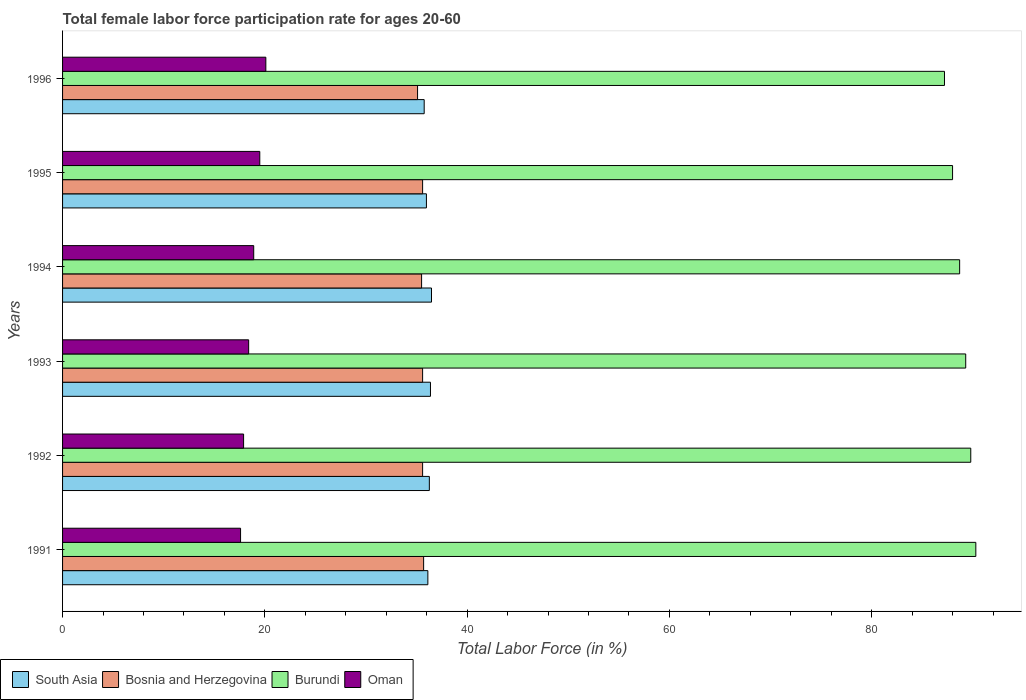How many different coloured bars are there?
Your answer should be compact. 4. How many groups of bars are there?
Offer a terse response. 6. How many bars are there on the 3rd tick from the top?
Offer a terse response. 4. How many bars are there on the 5th tick from the bottom?
Give a very brief answer. 4. What is the label of the 2nd group of bars from the top?
Ensure brevity in your answer.  1995. What is the female labor force participation rate in South Asia in 1992?
Ensure brevity in your answer.  36.27. Across all years, what is the maximum female labor force participation rate in Bosnia and Herzegovina?
Your answer should be very brief. 35.7. Across all years, what is the minimum female labor force participation rate in Oman?
Offer a very short reply. 17.6. In which year was the female labor force participation rate in South Asia maximum?
Provide a succinct answer. 1994. What is the total female labor force participation rate in South Asia in the graph?
Provide a short and direct response. 216.97. What is the difference between the female labor force participation rate in Oman in 1992 and that in 1994?
Your answer should be compact. -1. What is the difference between the female labor force participation rate in Oman in 1992 and the female labor force participation rate in Burundi in 1994?
Your response must be concise. -70.8. What is the average female labor force participation rate in Burundi per year?
Offer a terse response. 88.88. In the year 1992, what is the difference between the female labor force participation rate in Burundi and female labor force participation rate in South Asia?
Offer a terse response. 53.53. What is the ratio of the female labor force participation rate in South Asia in 1994 to that in 1996?
Give a very brief answer. 1.02. Is the difference between the female labor force participation rate in Burundi in 1994 and 1996 greater than the difference between the female labor force participation rate in South Asia in 1994 and 1996?
Offer a very short reply. Yes. What is the difference between the highest and the second highest female labor force participation rate in Oman?
Provide a short and direct response. 0.6. What is the difference between the highest and the lowest female labor force participation rate in Burundi?
Your response must be concise. 3.1. Is it the case that in every year, the sum of the female labor force participation rate in South Asia and female labor force participation rate in Oman is greater than the sum of female labor force participation rate in Burundi and female labor force participation rate in Bosnia and Herzegovina?
Your answer should be very brief. No. What does the 4th bar from the top in 1994 represents?
Provide a succinct answer. South Asia. What does the 1st bar from the bottom in 1996 represents?
Make the answer very short. South Asia. Is it the case that in every year, the sum of the female labor force participation rate in Oman and female labor force participation rate in South Asia is greater than the female labor force participation rate in Burundi?
Your answer should be compact. No. Are all the bars in the graph horizontal?
Offer a very short reply. Yes. How many years are there in the graph?
Your answer should be compact. 6. What is the difference between two consecutive major ticks on the X-axis?
Keep it short and to the point. 20. Does the graph contain any zero values?
Your answer should be compact. No. Where does the legend appear in the graph?
Your answer should be very brief. Bottom left. How many legend labels are there?
Ensure brevity in your answer.  4. What is the title of the graph?
Give a very brief answer. Total female labor force participation rate for ages 20-60. Does "Djibouti" appear as one of the legend labels in the graph?
Keep it short and to the point. No. What is the label or title of the Y-axis?
Make the answer very short. Years. What is the Total Labor Force (in %) of South Asia in 1991?
Keep it short and to the point. 36.12. What is the Total Labor Force (in %) in Bosnia and Herzegovina in 1991?
Provide a short and direct response. 35.7. What is the Total Labor Force (in %) of Burundi in 1991?
Offer a very short reply. 90.3. What is the Total Labor Force (in %) of Oman in 1991?
Your answer should be very brief. 17.6. What is the Total Labor Force (in %) of South Asia in 1992?
Ensure brevity in your answer.  36.27. What is the Total Labor Force (in %) of Bosnia and Herzegovina in 1992?
Offer a very short reply. 35.6. What is the Total Labor Force (in %) in Burundi in 1992?
Ensure brevity in your answer.  89.8. What is the Total Labor Force (in %) in Oman in 1992?
Your answer should be very brief. 17.9. What is the Total Labor Force (in %) in South Asia in 1993?
Your answer should be compact. 36.38. What is the Total Labor Force (in %) of Bosnia and Herzegovina in 1993?
Offer a terse response. 35.6. What is the Total Labor Force (in %) of Burundi in 1993?
Keep it short and to the point. 89.3. What is the Total Labor Force (in %) of Oman in 1993?
Your answer should be compact. 18.4. What is the Total Labor Force (in %) of South Asia in 1994?
Provide a succinct answer. 36.48. What is the Total Labor Force (in %) in Bosnia and Herzegovina in 1994?
Your answer should be very brief. 35.5. What is the Total Labor Force (in %) in Burundi in 1994?
Your answer should be very brief. 88.7. What is the Total Labor Force (in %) in Oman in 1994?
Keep it short and to the point. 18.9. What is the Total Labor Force (in %) of South Asia in 1995?
Ensure brevity in your answer.  35.98. What is the Total Labor Force (in %) in Bosnia and Herzegovina in 1995?
Provide a short and direct response. 35.6. What is the Total Labor Force (in %) in Burundi in 1995?
Give a very brief answer. 88. What is the Total Labor Force (in %) of Oman in 1995?
Offer a very short reply. 19.5. What is the Total Labor Force (in %) of South Asia in 1996?
Keep it short and to the point. 35.76. What is the Total Labor Force (in %) of Bosnia and Herzegovina in 1996?
Provide a short and direct response. 35.1. What is the Total Labor Force (in %) in Burundi in 1996?
Your response must be concise. 87.2. What is the Total Labor Force (in %) of Oman in 1996?
Offer a very short reply. 20.1. Across all years, what is the maximum Total Labor Force (in %) in South Asia?
Keep it short and to the point. 36.48. Across all years, what is the maximum Total Labor Force (in %) in Bosnia and Herzegovina?
Keep it short and to the point. 35.7. Across all years, what is the maximum Total Labor Force (in %) in Burundi?
Provide a succinct answer. 90.3. Across all years, what is the maximum Total Labor Force (in %) in Oman?
Give a very brief answer. 20.1. Across all years, what is the minimum Total Labor Force (in %) of South Asia?
Provide a short and direct response. 35.76. Across all years, what is the minimum Total Labor Force (in %) in Bosnia and Herzegovina?
Your answer should be compact. 35.1. Across all years, what is the minimum Total Labor Force (in %) of Burundi?
Give a very brief answer. 87.2. Across all years, what is the minimum Total Labor Force (in %) in Oman?
Make the answer very short. 17.6. What is the total Total Labor Force (in %) of South Asia in the graph?
Ensure brevity in your answer.  216.97. What is the total Total Labor Force (in %) in Bosnia and Herzegovina in the graph?
Make the answer very short. 213.1. What is the total Total Labor Force (in %) of Burundi in the graph?
Your response must be concise. 533.3. What is the total Total Labor Force (in %) in Oman in the graph?
Offer a terse response. 112.4. What is the difference between the Total Labor Force (in %) of South Asia in 1991 and that in 1992?
Your response must be concise. -0.15. What is the difference between the Total Labor Force (in %) of Bosnia and Herzegovina in 1991 and that in 1992?
Your answer should be compact. 0.1. What is the difference between the Total Labor Force (in %) of Burundi in 1991 and that in 1992?
Offer a very short reply. 0.5. What is the difference between the Total Labor Force (in %) of South Asia in 1991 and that in 1993?
Provide a short and direct response. -0.26. What is the difference between the Total Labor Force (in %) of Oman in 1991 and that in 1993?
Make the answer very short. -0.8. What is the difference between the Total Labor Force (in %) in South Asia in 1991 and that in 1994?
Make the answer very short. -0.36. What is the difference between the Total Labor Force (in %) of Burundi in 1991 and that in 1994?
Your response must be concise. 1.6. What is the difference between the Total Labor Force (in %) of South Asia in 1991 and that in 1995?
Your answer should be compact. 0.14. What is the difference between the Total Labor Force (in %) of Burundi in 1991 and that in 1995?
Ensure brevity in your answer.  2.3. What is the difference between the Total Labor Force (in %) in South Asia in 1991 and that in 1996?
Provide a short and direct response. 0.36. What is the difference between the Total Labor Force (in %) in Bosnia and Herzegovina in 1991 and that in 1996?
Keep it short and to the point. 0.6. What is the difference between the Total Labor Force (in %) in South Asia in 1992 and that in 1993?
Offer a very short reply. -0.11. What is the difference between the Total Labor Force (in %) of Burundi in 1992 and that in 1993?
Your answer should be compact. 0.5. What is the difference between the Total Labor Force (in %) of South Asia in 1992 and that in 1994?
Make the answer very short. -0.21. What is the difference between the Total Labor Force (in %) in Bosnia and Herzegovina in 1992 and that in 1994?
Provide a succinct answer. 0.1. What is the difference between the Total Labor Force (in %) in Oman in 1992 and that in 1994?
Offer a terse response. -1. What is the difference between the Total Labor Force (in %) of South Asia in 1992 and that in 1995?
Provide a short and direct response. 0.29. What is the difference between the Total Labor Force (in %) of Burundi in 1992 and that in 1995?
Provide a succinct answer. 1.8. What is the difference between the Total Labor Force (in %) in Oman in 1992 and that in 1995?
Your answer should be compact. -1.6. What is the difference between the Total Labor Force (in %) of South Asia in 1992 and that in 1996?
Ensure brevity in your answer.  0.51. What is the difference between the Total Labor Force (in %) of Burundi in 1992 and that in 1996?
Your answer should be very brief. 2.6. What is the difference between the Total Labor Force (in %) of Oman in 1992 and that in 1996?
Your answer should be very brief. -2.2. What is the difference between the Total Labor Force (in %) of South Asia in 1993 and that in 1994?
Your answer should be very brief. -0.1. What is the difference between the Total Labor Force (in %) in South Asia in 1993 and that in 1995?
Provide a succinct answer. 0.4. What is the difference between the Total Labor Force (in %) of South Asia in 1993 and that in 1996?
Provide a short and direct response. 0.62. What is the difference between the Total Labor Force (in %) in Bosnia and Herzegovina in 1993 and that in 1996?
Your response must be concise. 0.5. What is the difference between the Total Labor Force (in %) of South Asia in 1994 and that in 1995?
Offer a terse response. 0.5. What is the difference between the Total Labor Force (in %) in Burundi in 1994 and that in 1995?
Provide a short and direct response. 0.7. What is the difference between the Total Labor Force (in %) of South Asia in 1994 and that in 1996?
Provide a succinct answer. 0.72. What is the difference between the Total Labor Force (in %) in Bosnia and Herzegovina in 1994 and that in 1996?
Offer a very short reply. 0.4. What is the difference between the Total Labor Force (in %) of South Asia in 1995 and that in 1996?
Ensure brevity in your answer.  0.22. What is the difference between the Total Labor Force (in %) of Burundi in 1995 and that in 1996?
Provide a succinct answer. 0.8. What is the difference between the Total Labor Force (in %) in Oman in 1995 and that in 1996?
Offer a very short reply. -0.6. What is the difference between the Total Labor Force (in %) in South Asia in 1991 and the Total Labor Force (in %) in Bosnia and Herzegovina in 1992?
Your response must be concise. 0.52. What is the difference between the Total Labor Force (in %) of South Asia in 1991 and the Total Labor Force (in %) of Burundi in 1992?
Offer a very short reply. -53.68. What is the difference between the Total Labor Force (in %) of South Asia in 1991 and the Total Labor Force (in %) of Oman in 1992?
Make the answer very short. 18.22. What is the difference between the Total Labor Force (in %) of Bosnia and Herzegovina in 1991 and the Total Labor Force (in %) of Burundi in 1992?
Provide a short and direct response. -54.1. What is the difference between the Total Labor Force (in %) in Bosnia and Herzegovina in 1991 and the Total Labor Force (in %) in Oman in 1992?
Ensure brevity in your answer.  17.8. What is the difference between the Total Labor Force (in %) in Burundi in 1991 and the Total Labor Force (in %) in Oman in 1992?
Offer a very short reply. 72.4. What is the difference between the Total Labor Force (in %) in South Asia in 1991 and the Total Labor Force (in %) in Bosnia and Herzegovina in 1993?
Keep it short and to the point. 0.52. What is the difference between the Total Labor Force (in %) of South Asia in 1991 and the Total Labor Force (in %) of Burundi in 1993?
Keep it short and to the point. -53.18. What is the difference between the Total Labor Force (in %) in South Asia in 1991 and the Total Labor Force (in %) in Oman in 1993?
Your answer should be very brief. 17.72. What is the difference between the Total Labor Force (in %) in Bosnia and Herzegovina in 1991 and the Total Labor Force (in %) in Burundi in 1993?
Offer a very short reply. -53.6. What is the difference between the Total Labor Force (in %) in Bosnia and Herzegovina in 1991 and the Total Labor Force (in %) in Oman in 1993?
Your answer should be compact. 17.3. What is the difference between the Total Labor Force (in %) of Burundi in 1991 and the Total Labor Force (in %) of Oman in 1993?
Your response must be concise. 71.9. What is the difference between the Total Labor Force (in %) of South Asia in 1991 and the Total Labor Force (in %) of Bosnia and Herzegovina in 1994?
Ensure brevity in your answer.  0.62. What is the difference between the Total Labor Force (in %) of South Asia in 1991 and the Total Labor Force (in %) of Burundi in 1994?
Ensure brevity in your answer.  -52.58. What is the difference between the Total Labor Force (in %) of South Asia in 1991 and the Total Labor Force (in %) of Oman in 1994?
Give a very brief answer. 17.22. What is the difference between the Total Labor Force (in %) in Bosnia and Herzegovina in 1991 and the Total Labor Force (in %) in Burundi in 1994?
Keep it short and to the point. -53. What is the difference between the Total Labor Force (in %) of Bosnia and Herzegovina in 1991 and the Total Labor Force (in %) of Oman in 1994?
Your response must be concise. 16.8. What is the difference between the Total Labor Force (in %) of Burundi in 1991 and the Total Labor Force (in %) of Oman in 1994?
Make the answer very short. 71.4. What is the difference between the Total Labor Force (in %) in South Asia in 1991 and the Total Labor Force (in %) in Bosnia and Herzegovina in 1995?
Provide a succinct answer. 0.52. What is the difference between the Total Labor Force (in %) in South Asia in 1991 and the Total Labor Force (in %) in Burundi in 1995?
Offer a very short reply. -51.88. What is the difference between the Total Labor Force (in %) of South Asia in 1991 and the Total Labor Force (in %) of Oman in 1995?
Ensure brevity in your answer.  16.62. What is the difference between the Total Labor Force (in %) in Bosnia and Herzegovina in 1991 and the Total Labor Force (in %) in Burundi in 1995?
Provide a succinct answer. -52.3. What is the difference between the Total Labor Force (in %) of Bosnia and Herzegovina in 1991 and the Total Labor Force (in %) of Oman in 1995?
Provide a succinct answer. 16.2. What is the difference between the Total Labor Force (in %) of Burundi in 1991 and the Total Labor Force (in %) of Oman in 1995?
Your answer should be compact. 70.8. What is the difference between the Total Labor Force (in %) in South Asia in 1991 and the Total Labor Force (in %) in Bosnia and Herzegovina in 1996?
Give a very brief answer. 1.02. What is the difference between the Total Labor Force (in %) of South Asia in 1991 and the Total Labor Force (in %) of Burundi in 1996?
Offer a terse response. -51.08. What is the difference between the Total Labor Force (in %) in South Asia in 1991 and the Total Labor Force (in %) in Oman in 1996?
Provide a short and direct response. 16.02. What is the difference between the Total Labor Force (in %) in Bosnia and Herzegovina in 1991 and the Total Labor Force (in %) in Burundi in 1996?
Ensure brevity in your answer.  -51.5. What is the difference between the Total Labor Force (in %) of Burundi in 1991 and the Total Labor Force (in %) of Oman in 1996?
Provide a short and direct response. 70.2. What is the difference between the Total Labor Force (in %) of South Asia in 1992 and the Total Labor Force (in %) of Bosnia and Herzegovina in 1993?
Provide a short and direct response. 0.67. What is the difference between the Total Labor Force (in %) of South Asia in 1992 and the Total Labor Force (in %) of Burundi in 1993?
Give a very brief answer. -53.03. What is the difference between the Total Labor Force (in %) in South Asia in 1992 and the Total Labor Force (in %) in Oman in 1993?
Your answer should be very brief. 17.87. What is the difference between the Total Labor Force (in %) of Bosnia and Herzegovina in 1992 and the Total Labor Force (in %) of Burundi in 1993?
Give a very brief answer. -53.7. What is the difference between the Total Labor Force (in %) of Burundi in 1992 and the Total Labor Force (in %) of Oman in 1993?
Ensure brevity in your answer.  71.4. What is the difference between the Total Labor Force (in %) in South Asia in 1992 and the Total Labor Force (in %) in Bosnia and Herzegovina in 1994?
Offer a terse response. 0.77. What is the difference between the Total Labor Force (in %) of South Asia in 1992 and the Total Labor Force (in %) of Burundi in 1994?
Your response must be concise. -52.43. What is the difference between the Total Labor Force (in %) in South Asia in 1992 and the Total Labor Force (in %) in Oman in 1994?
Make the answer very short. 17.37. What is the difference between the Total Labor Force (in %) in Bosnia and Herzegovina in 1992 and the Total Labor Force (in %) in Burundi in 1994?
Offer a very short reply. -53.1. What is the difference between the Total Labor Force (in %) in Burundi in 1992 and the Total Labor Force (in %) in Oman in 1994?
Your answer should be compact. 70.9. What is the difference between the Total Labor Force (in %) of South Asia in 1992 and the Total Labor Force (in %) of Bosnia and Herzegovina in 1995?
Give a very brief answer. 0.67. What is the difference between the Total Labor Force (in %) in South Asia in 1992 and the Total Labor Force (in %) in Burundi in 1995?
Make the answer very short. -51.73. What is the difference between the Total Labor Force (in %) of South Asia in 1992 and the Total Labor Force (in %) of Oman in 1995?
Your response must be concise. 16.77. What is the difference between the Total Labor Force (in %) in Bosnia and Herzegovina in 1992 and the Total Labor Force (in %) in Burundi in 1995?
Keep it short and to the point. -52.4. What is the difference between the Total Labor Force (in %) of Bosnia and Herzegovina in 1992 and the Total Labor Force (in %) of Oman in 1995?
Your answer should be very brief. 16.1. What is the difference between the Total Labor Force (in %) in Burundi in 1992 and the Total Labor Force (in %) in Oman in 1995?
Your response must be concise. 70.3. What is the difference between the Total Labor Force (in %) in South Asia in 1992 and the Total Labor Force (in %) in Bosnia and Herzegovina in 1996?
Your response must be concise. 1.17. What is the difference between the Total Labor Force (in %) of South Asia in 1992 and the Total Labor Force (in %) of Burundi in 1996?
Your response must be concise. -50.93. What is the difference between the Total Labor Force (in %) of South Asia in 1992 and the Total Labor Force (in %) of Oman in 1996?
Ensure brevity in your answer.  16.17. What is the difference between the Total Labor Force (in %) in Bosnia and Herzegovina in 1992 and the Total Labor Force (in %) in Burundi in 1996?
Your answer should be very brief. -51.6. What is the difference between the Total Labor Force (in %) of Burundi in 1992 and the Total Labor Force (in %) of Oman in 1996?
Your answer should be compact. 69.7. What is the difference between the Total Labor Force (in %) in South Asia in 1993 and the Total Labor Force (in %) in Bosnia and Herzegovina in 1994?
Make the answer very short. 0.88. What is the difference between the Total Labor Force (in %) in South Asia in 1993 and the Total Labor Force (in %) in Burundi in 1994?
Make the answer very short. -52.32. What is the difference between the Total Labor Force (in %) of South Asia in 1993 and the Total Labor Force (in %) of Oman in 1994?
Offer a terse response. 17.48. What is the difference between the Total Labor Force (in %) of Bosnia and Herzegovina in 1993 and the Total Labor Force (in %) of Burundi in 1994?
Your answer should be very brief. -53.1. What is the difference between the Total Labor Force (in %) in Bosnia and Herzegovina in 1993 and the Total Labor Force (in %) in Oman in 1994?
Provide a succinct answer. 16.7. What is the difference between the Total Labor Force (in %) of Burundi in 1993 and the Total Labor Force (in %) of Oman in 1994?
Provide a short and direct response. 70.4. What is the difference between the Total Labor Force (in %) of South Asia in 1993 and the Total Labor Force (in %) of Bosnia and Herzegovina in 1995?
Your response must be concise. 0.78. What is the difference between the Total Labor Force (in %) in South Asia in 1993 and the Total Labor Force (in %) in Burundi in 1995?
Your response must be concise. -51.62. What is the difference between the Total Labor Force (in %) of South Asia in 1993 and the Total Labor Force (in %) of Oman in 1995?
Your response must be concise. 16.88. What is the difference between the Total Labor Force (in %) of Bosnia and Herzegovina in 1993 and the Total Labor Force (in %) of Burundi in 1995?
Offer a very short reply. -52.4. What is the difference between the Total Labor Force (in %) of Bosnia and Herzegovina in 1993 and the Total Labor Force (in %) of Oman in 1995?
Ensure brevity in your answer.  16.1. What is the difference between the Total Labor Force (in %) in Burundi in 1993 and the Total Labor Force (in %) in Oman in 1995?
Offer a very short reply. 69.8. What is the difference between the Total Labor Force (in %) of South Asia in 1993 and the Total Labor Force (in %) of Bosnia and Herzegovina in 1996?
Provide a short and direct response. 1.28. What is the difference between the Total Labor Force (in %) of South Asia in 1993 and the Total Labor Force (in %) of Burundi in 1996?
Ensure brevity in your answer.  -50.82. What is the difference between the Total Labor Force (in %) of South Asia in 1993 and the Total Labor Force (in %) of Oman in 1996?
Provide a succinct answer. 16.28. What is the difference between the Total Labor Force (in %) in Bosnia and Herzegovina in 1993 and the Total Labor Force (in %) in Burundi in 1996?
Your answer should be compact. -51.6. What is the difference between the Total Labor Force (in %) of Bosnia and Herzegovina in 1993 and the Total Labor Force (in %) of Oman in 1996?
Your answer should be very brief. 15.5. What is the difference between the Total Labor Force (in %) of Burundi in 1993 and the Total Labor Force (in %) of Oman in 1996?
Offer a very short reply. 69.2. What is the difference between the Total Labor Force (in %) of South Asia in 1994 and the Total Labor Force (in %) of Bosnia and Herzegovina in 1995?
Your answer should be very brief. 0.88. What is the difference between the Total Labor Force (in %) in South Asia in 1994 and the Total Labor Force (in %) in Burundi in 1995?
Provide a succinct answer. -51.52. What is the difference between the Total Labor Force (in %) in South Asia in 1994 and the Total Labor Force (in %) in Oman in 1995?
Provide a succinct answer. 16.98. What is the difference between the Total Labor Force (in %) in Bosnia and Herzegovina in 1994 and the Total Labor Force (in %) in Burundi in 1995?
Offer a terse response. -52.5. What is the difference between the Total Labor Force (in %) in Bosnia and Herzegovina in 1994 and the Total Labor Force (in %) in Oman in 1995?
Provide a short and direct response. 16. What is the difference between the Total Labor Force (in %) in Burundi in 1994 and the Total Labor Force (in %) in Oman in 1995?
Your answer should be compact. 69.2. What is the difference between the Total Labor Force (in %) of South Asia in 1994 and the Total Labor Force (in %) of Bosnia and Herzegovina in 1996?
Give a very brief answer. 1.38. What is the difference between the Total Labor Force (in %) in South Asia in 1994 and the Total Labor Force (in %) in Burundi in 1996?
Ensure brevity in your answer.  -50.72. What is the difference between the Total Labor Force (in %) in South Asia in 1994 and the Total Labor Force (in %) in Oman in 1996?
Provide a short and direct response. 16.38. What is the difference between the Total Labor Force (in %) of Bosnia and Herzegovina in 1994 and the Total Labor Force (in %) of Burundi in 1996?
Your answer should be very brief. -51.7. What is the difference between the Total Labor Force (in %) of Burundi in 1994 and the Total Labor Force (in %) of Oman in 1996?
Provide a short and direct response. 68.6. What is the difference between the Total Labor Force (in %) of South Asia in 1995 and the Total Labor Force (in %) of Bosnia and Herzegovina in 1996?
Keep it short and to the point. 0.88. What is the difference between the Total Labor Force (in %) of South Asia in 1995 and the Total Labor Force (in %) of Burundi in 1996?
Your response must be concise. -51.22. What is the difference between the Total Labor Force (in %) of South Asia in 1995 and the Total Labor Force (in %) of Oman in 1996?
Provide a short and direct response. 15.88. What is the difference between the Total Labor Force (in %) in Bosnia and Herzegovina in 1995 and the Total Labor Force (in %) in Burundi in 1996?
Provide a succinct answer. -51.6. What is the difference between the Total Labor Force (in %) of Bosnia and Herzegovina in 1995 and the Total Labor Force (in %) of Oman in 1996?
Your answer should be very brief. 15.5. What is the difference between the Total Labor Force (in %) in Burundi in 1995 and the Total Labor Force (in %) in Oman in 1996?
Provide a succinct answer. 67.9. What is the average Total Labor Force (in %) in South Asia per year?
Your answer should be very brief. 36.16. What is the average Total Labor Force (in %) in Bosnia and Herzegovina per year?
Provide a short and direct response. 35.52. What is the average Total Labor Force (in %) of Burundi per year?
Offer a terse response. 88.88. What is the average Total Labor Force (in %) of Oman per year?
Your answer should be compact. 18.73. In the year 1991, what is the difference between the Total Labor Force (in %) in South Asia and Total Labor Force (in %) in Bosnia and Herzegovina?
Ensure brevity in your answer.  0.42. In the year 1991, what is the difference between the Total Labor Force (in %) of South Asia and Total Labor Force (in %) of Burundi?
Provide a succinct answer. -54.18. In the year 1991, what is the difference between the Total Labor Force (in %) in South Asia and Total Labor Force (in %) in Oman?
Offer a very short reply. 18.52. In the year 1991, what is the difference between the Total Labor Force (in %) in Bosnia and Herzegovina and Total Labor Force (in %) in Burundi?
Provide a short and direct response. -54.6. In the year 1991, what is the difference between the Total Labor Force (in %) in Burundi and Total Labor Force (in %) in Oman?
Provide a succinct answer. 72.7. In the year 1992, what is the difference between the Total Labor Force (in %) of South Asia and Total Labor Force (in %) of Bosnia and Herzegovina?
Your answer should be very brief. 0.67. In the year 1992, what is the difference between the Total Labor Force (in %) in South Asia and Total Labor Force (in %) in Burundi?
Offer a very short reply. -53.53. In the year 1992, what is the difference between the Total Labor Force (in %) in South Asia and Total Labor Force (in %) in Oman?
Your answer should be compact. 18.37. In the year 1992, what is the difference between the Total Labor Force (in %) in Bosnia and Herzegovina and Total Labor Force (in %) in Burundi?
Your answer should be compact. -54.2. In the year 1992, what is the difference between the Total Labor Force (in %) in Burundi and Total Labor Force (in %) in Oman?
Offer a very short reply. 71.9. In the year 1993, what is the difference between the Total Labor Force (in %) in South Asia and Total Labor Force (in %) in Bosnia and Herzegovina?
Give a very brief answer. 0.78. In the year 1993, what is the difference between the Total Labor Force (in %) of South Asia and Total Labor Force (in %) of Burundi?
Your answer should be very brief. -52.92. In the year 1993, what is the difference between the Total Labor Force (in %) in South Asia and Total Labor Force (in %) in Oman?
Provide a succinct answer. 17.98. In the year 1993, what is the difference between the Total Labor Force (in %) of Bosnia and Herzegovina and Total Labor Force (in %) of Burundi?
Ensure brevity in your answer.  -53.7. In the year 1993, what is the difference between the Total Labor Force (in %) of Bosnia and Herzegovina and Total Labor Force (in %) of Oman?
Provide a succinct answer. 17.2. In the year 1993, what is the difference between the Total Labor Force (in %) in Burundi and Total Labor Force (in %) in Oman?
Your answer should be compact. 70.9. In the year 1994, what is the difference between the Total Labor Force (in %) of South Asia and Total Labor Force (in %) of Bosnia and Herzegovina?
Provide a short and direct response. 0.98. In the year 1994, what is the difference between the Total Labor Force (in %) in South Asia and Total Labor Force (in %) in Burundi?
Offer a terse response. -52.22. In the year 1994, what is the difference between the Total Labor Force (in %) of South Asia and Total Labor Force (in %) of Oman?
Ensure brevity in your answer.  17.58. In the year 1994, what is the difference between the Total Labor Force (in %) in Bosnia and Herzegovina and Total Labor Force (in %) in Burundi?
Offer a very short reply. -53.2. In the year 1994, what is the difference between the Total Labor Force (in %) of Bosnia and Herzegovina and Total Labor Force (in %) of Oman?
Offer a terse response. 16.6. In the year 1994, what is the difference between the Total Labor Force (in %) in Burundi and Total Labor Force (in %) in Oman?
Give a very brief answer. 69.8. In the year 1995, what is the difference between the Total Labor Force (in %) of South Asia and Total Labor Force (in %) of Bosnia and Herzegovina?
Your answer should be compact. 0.38. In the year 1995, what is the difference between the Total Labor Force (in %) in South Asia and Total Labor Force (in %) in Burundi?
Your response must be concise. -52.02. In the year 1995, what is the difference between the Total Labor Force (in %) in South Asia and Total Labor Force (in %) in Oman?
Provide a succinct answer. 16.48. In the year 1995, what is the difference between the Total Labor Force (in %) in Bosnia and Herzegovina and Total Labor Force (in %) in Burundi?
Offer a terse response. -52.4. In the year 1995, what is the difference between the Total Labor Force (in %) of Burundi and Total Labor Force (in %) of Oman?
Your answer should be compact. 68.5. In the year 1996, what is the difference between the Total Labor Force (in %) in South Asia and Total Labor Force (in %) in Bosnia and Herzegovina?
Your answer should be compact. 0.66. In the year 1996, what is the difference between the Total Labor Force (in %) in South Asia and Total Labor Force (in %) in Burundi?
Keep it short and to the point. -51.45. In the year 1996, what is the difference between the Total Labor Force (in %) in South Asia and Total Labor Force (in %) in Oman?
Offer a very short reply. 15.65. In the year 1996, what is the difference between the Total Labor Force (in %) of Bosnia and Herzegovina and Total Labor Force (in %) of Burundi?
Offer a very short reply. -52.1. In the year 1996, what is the difference between the Total Labor Force (in %) of Bosnia and Herzegovina and Total Labor Force (in %) of Oman?
Provide a short and direct response. 15. In the year 1996, what is the difference between the Total Labor Force (in %) in Burundi and Total Labor Force (in %) in Oman?
Provide a succinct answer. 67.1. What is the ratio of the Total Labor Force (in %) of South Asia in 1991 to that in 1992?
Provide a short and direct response. 1. What is the ratio of the Total Labor Force (in %) of Bosnia and Herzegovina in 1991 to that in 1992?
Make the answer very short. 1. What is the ratio of the Total Labor Force (in %) in Burundi in 1991 to that in 1992?
Your answer should be very brief. 1.01. What is the ratio of the Total Labor Force (in %) in Oman in 1991 to that in 1992?
Offer a terse response. 0.98. What is the ratio of the Total Labor Force (in %) of Bosnia and Herzegovina in 1991 to that in 1993?
Your answer should be very brief. 1. What is the ratio of the Total Labor Force (in %) in Burundi in 1991 to that in 1993?
Your answer should be compact. 1.01. What is the ratio of the Total Labor Force (in %) of Oman in 1991 to that in 1993?
Ensure brevity in your answer.  0.96. What is the ratio of the Total Labor Force (in %) in Bosnia and Herzegovina in 1991 to that in 1994?
Your answer should be very brief. 1.01. What is the ratio of the Total Labor Force (in %) of Burundi in 1991 to that in 1994?
Your answer should be compact. 1.02. What is the ratio of the Total Labor Force (in %) in Oman in 1991 to that in 1994?
Keep it short and to the point. 0.93. What is the ratio of the Total Labor Force (in %) in South Asia in 1991 to that in 1995?
Offer a terse response. 1. What is the ratio of the Total Labor Force (in %) in Burundi in 1991 to that in 1995?
Give a very brief answer. 1.03. What is the ratio of the Total Labor Force (in %) in Oman in 1991 to that in 1995?
Ensure brevity in your answer.  0.9. What is the ratio of the Total Labor Force (in %) in South Asia in 1991 to that in 1996?
Provide a short and direct response. 1.01. What is the ratio of the Total Labor Force (in %) of Bosnia and Herzegovina in 1991 to that in 1996?
Provide a succinct answer. 1.02. What is the ratio of the Total Labor Force (in %) in Burundi in 1991 to that in 1996?
Provide a succinct answer. 1.04. What is the ratio of the Total Labor Force (in %) in Oman in 1991 to that in 1996?
Give a very brief answer. 0.88. What is the ratio of the Total Labor Force (in %) of Bosnia and Herzegovina in 1992 to that in 1993?
Give a very brief answer. 1. What is the ratio of the Total Labor Force (in %) in Burundi in 1992 to that in 1993?
Your answer should be very brief. 1.01. What is the ratio of the Total Labor Force (in %) in Oman in 1992 to that in 1993?
Ensure brevity in your answer.  0.97. What is the ratio of the Total Labor Force (in %) in Burundi in 1992 to that in 1994?
Ensure brevity in your answer.  1.01. What is the ratio of the Total Labor Force (in %) of Oman in 1992 to that in 1994?
Make the answer very short. 0.95. What is the ratio of the Total Labor Force (in %) in South Asia in 1992 to that in 1995?
Keep it short and to the point. 1.01. What is the ratio of the Total Labor Force (in %) of Bosnia and Herzegovina in 1992 to that in 1995?
Your answer should be compact. 1. What is the ratio of the Total Labor Force (in %) of Burundi in 1992 to that in 1995?
Your answer should be very brief. 1.02. What is the ratio of the Total Labor Force (in %) of Oman in 1992 to that in 1995?
Give a very brief answer. 0.92. What is the ratio of the Total Labor Force (in %) of South Asia in 1992 to that in 1996?
Your answer should be compact. 1.01. What is the ratio of the Total Labor Force (in %) in Bosnia and Herzegovina in 1992 to that in 1996?
Ensure brevity in your answer.  1.01. What is the ratio of the Total Labor Force (in %) in Burundi in 1992 to that in 1996?
Offer a very short reply. 1.03. What is the ratio of the Total Labor Force (in %) of Oman in 1992 to that in 1996?
Give a very brief answer. 0.89. What is the ratio of the Total Labor Force (in %) of South Asia in 1993 to that in 1994?
Your response must be concise. 1. What is the ratio of the Total Labor Force (in %) in Burundi in 1993 to that in 1994?
Offer a very short reply. 1.01. What is the ratio of the Total Labor Force (in %) of Oman in 1993 to that in 1994?
Your answer should be very brief. 0.97. What is the ratio of the Total Labor Force (in %) of South Asia in 1993 to that in 1995?
Your response must be concise. 1.01. What is the ratio of the Total Labor Force (in %) of Burundi in 1993 to that in 1995?
Offer a very short reply. 1.01. What is the ratio of the Total Labor Force (in %) of Oman in 1993 to that in 1995?
Ensure brevity in your answer.  0.94. What is the ratio of the Total Labor Force (in %) in South Asia in 1993 to that in 1996?
Provide a succinct answer. 1.02. What is the ratio of the Total Labor Force (in %) of Bosnia and Herzegovina in 1993 to that in 1996?
Provide a short and direct response. 1.01. What is the ratio of the Total Labor Force (in %) in Burundi in 1993 to that in 1996?
Ensure brevity in your answer.  1.02. What is the ratio of the Total Labor Force (in %) of Oman in 1993 to that in 1996?
Your answer should be very brief. 0.92. What is the ratio of the Total Labor Force (in %) of Bosnia and Herzegovina in 1994 to that in 1995?
Provide a short and direct response. 1. What is the ratio of the Total Labor Force (in %) of Oman in 1994 to that in 1995?
Keep it short and to the point. 0.97. What is the ratio of the Total Labor Force (in %) of South Asia in 1994 to that in 1996?
Provide a succinct answer. 1.02. What is the ratio of the Total Labor Force (in %) in Bosnia and Herzegovina in 1994 to that in 1996?
Give a very brief answer. 1.01. What is the ratio of the Total Labor Force (in %) of Burundi in 1994 to that in 1996?
Provide a succinct answer. 1.02. What is the ratio of the Total Labor Force (in %) of Oman in 1994 to that in 1996?
Provide a succinct answer. 0.94. What is the ratio of the Total Labor Force (in %) of South Asia in 1995 to that in 1996?
Your response must be concise. 1.01. What is the ratio of the Total Labor Force (in %) of Bosnia and Herzegovina in 1995 to that in 1996?
Provide a short and direct response. 1.01. What is the ratio of the Total Labor Force (in %) in Burundi in 1995 to that in 1996?
Your answer should be compact. 1.01. What is the ratio of the Total Labor Force (in %) in Oman in 1995 to that in 1996?
Provide a short and direct response. 0.97. What is the difference between the highest and the second highest Total Labor Force (in %) in South Asia?
Provide a succinct answer. 0.1. What is the difference between the highest and the second highest Total Labor Force (in %) in Bosnia and Herzegovina?
Give a very brief answer. 0.1. What is the difference between the highest and the second highest Total Labor Force (in %) of Burundi?
Your answer should be very brief. 0.5. What is the difference between the highest and the second highest Total Labor Force (in %) of Oman?
Provide a succinct answer. 0.6. What is the difference between the highest and the lowest Total Labor Force (in %) of South Asia?
Give a very brief answer. 0.72. What is the difference between the highest and the lowest Total Labor Force (in %) in Bosnia and Herzegovina?
Keep it short and to the point. 0.6. 